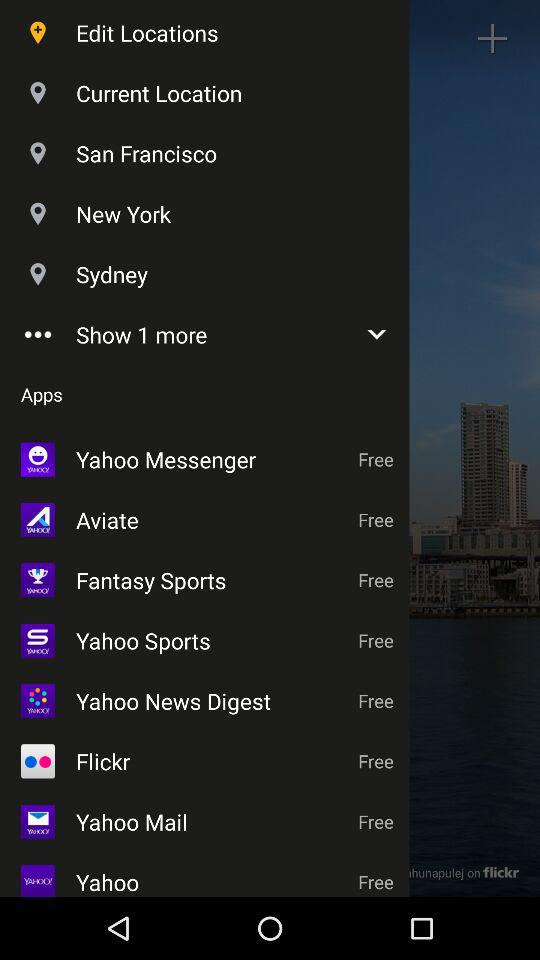What are the names of free applications? The names of the applications are "Yahoo Messenger", "Aviate", "Fantasy Sports", "Yahoo Sports", "Yahoo News Digest", "Flickr", "Yahoo Mail", and "Yahoo". 